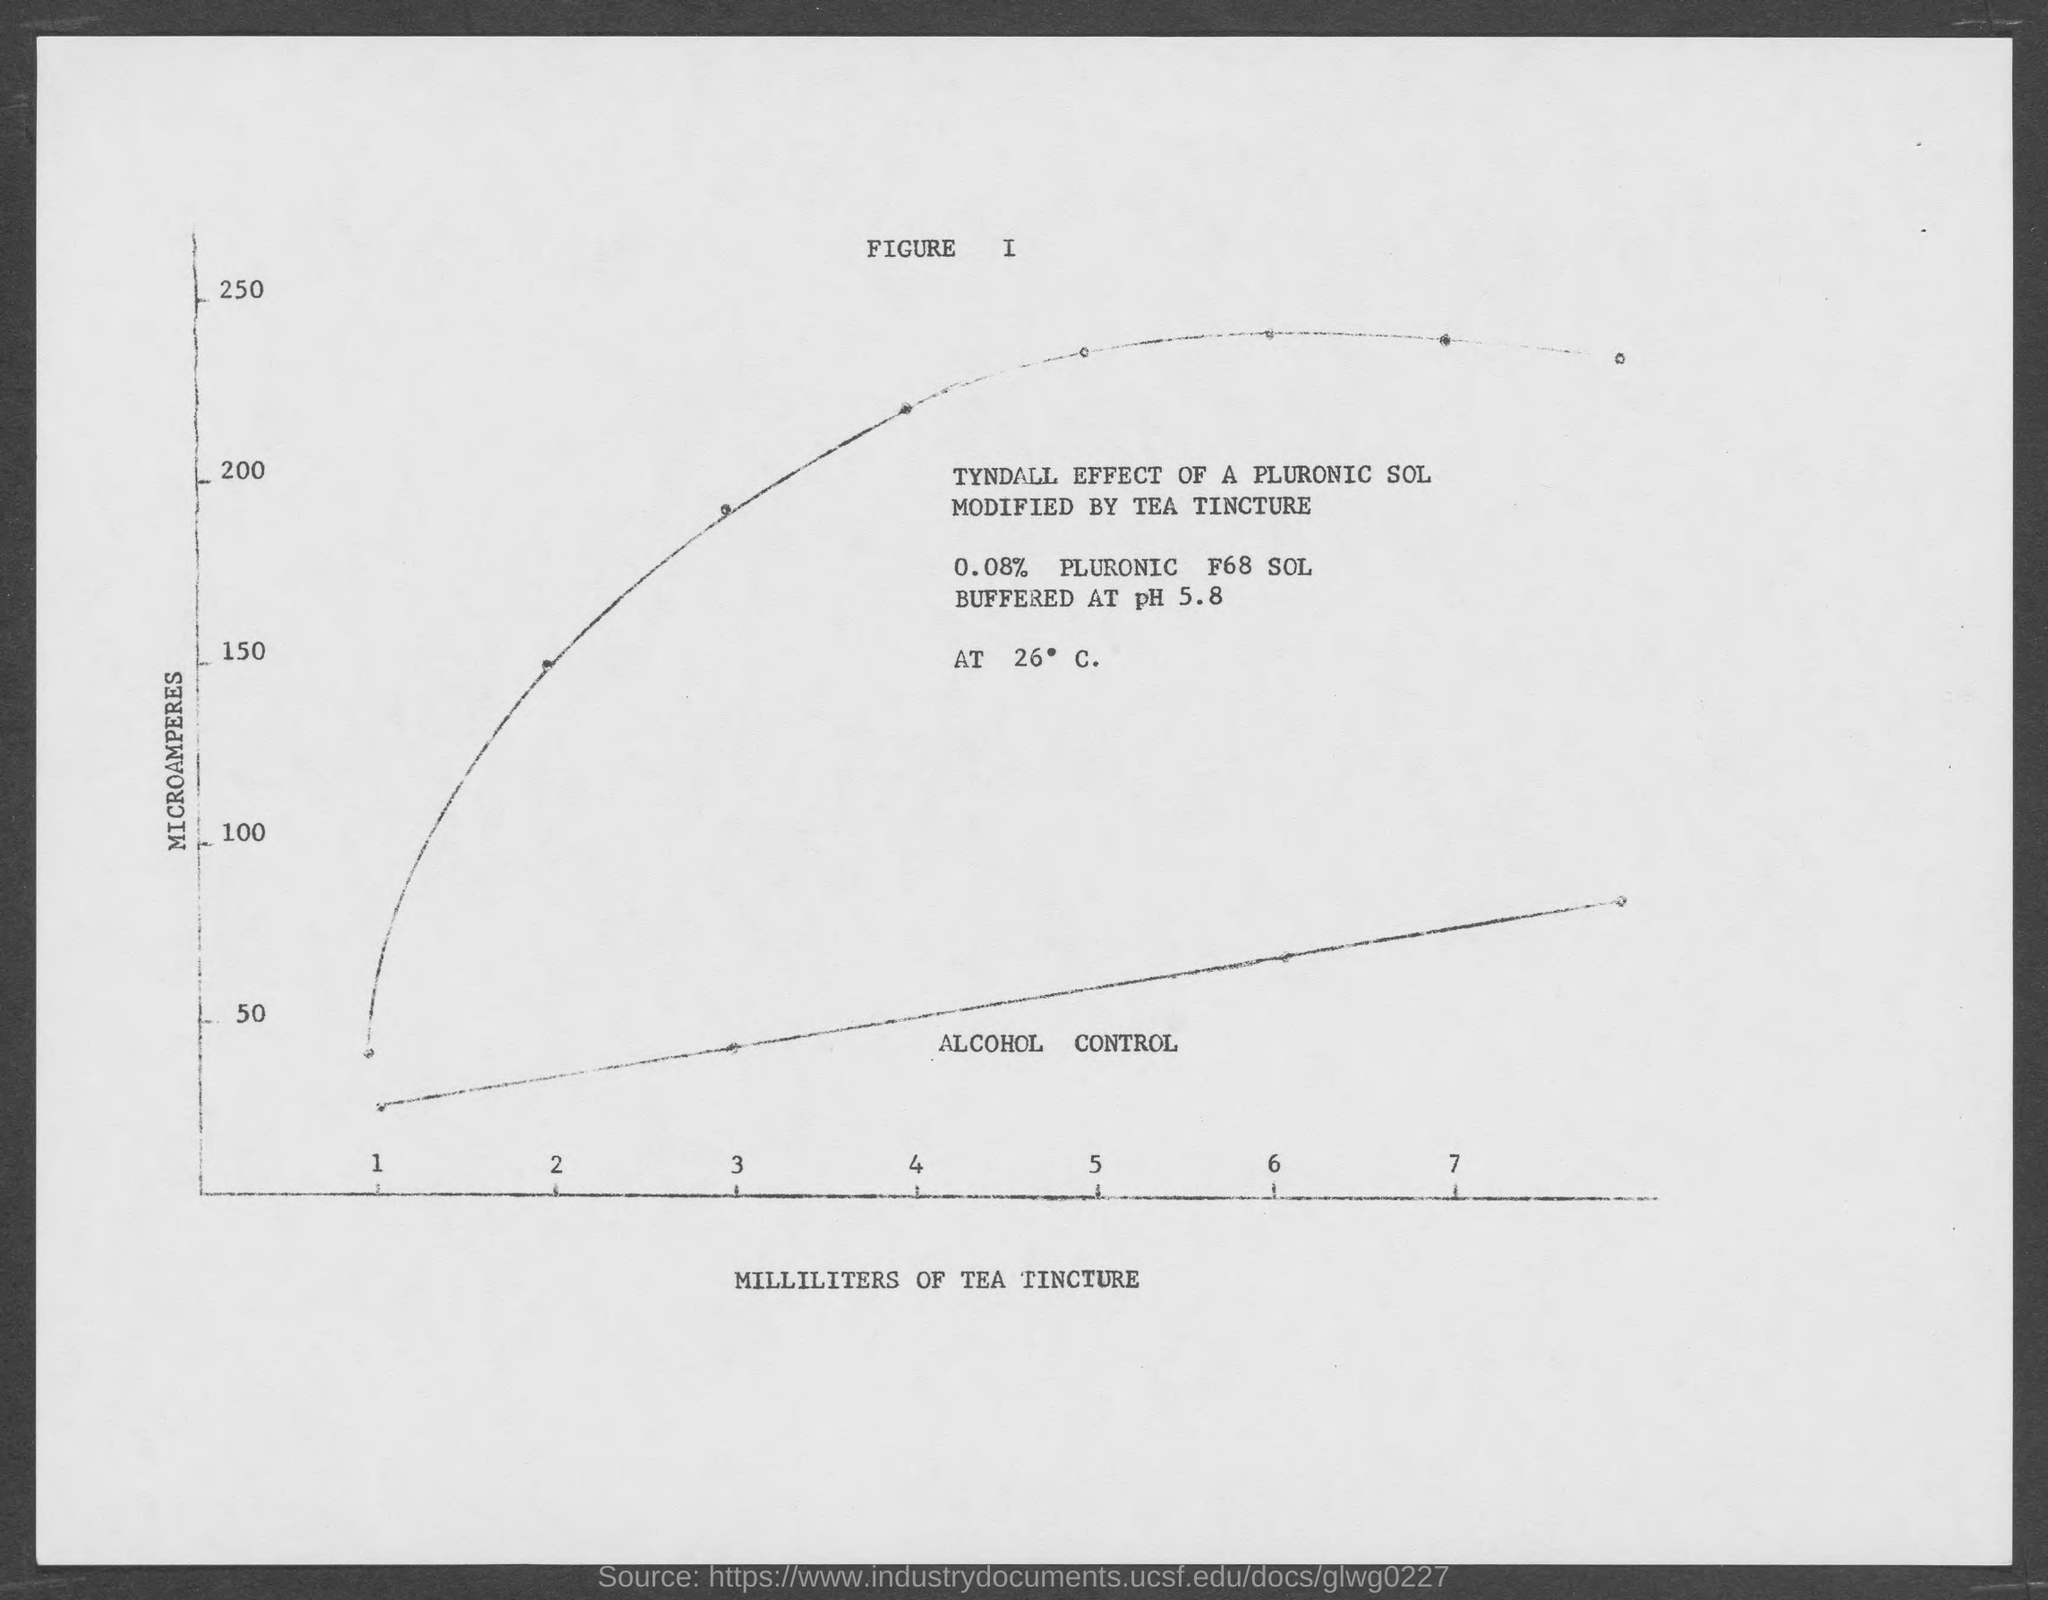What is on the X-axis of the graph?
Your response must be concise. MILLILITERS OF TEA TINCTURE. What is on the Y-axis of the  graph?
Your answer should be compact. MICROAMPERES. What effect of a pluronic sol is shown in the graph?
Offer a terse response. TYNDALL EFFECT. What substance is used here to modify TYNDALL EFFECT OF A PLURONIC SOL?
Keep it short and to the point. TEA TINCTURE. 0.08% PLURONIC F68 SOL is buffered at what pH?
Keep it short and to the point. PH 5.8. What percentage of PLURONIC F68 SOL is buffered at pH 5.8?
Your answer should be very brief. 0.08. What is the maximum value of "MICROAMPERES" taken in Y-axis of the graph?
Keep it short and to the point. 250. What is the minimum value of "MICROAMPERES" taken in Y-axis of the graph?
Give a very brief answer. 50. What is the maximum value of "MILLILITERS OF TEA TINCTURE" taken in X-axis of the graph?
Ensure brevity in your answer.  7. 